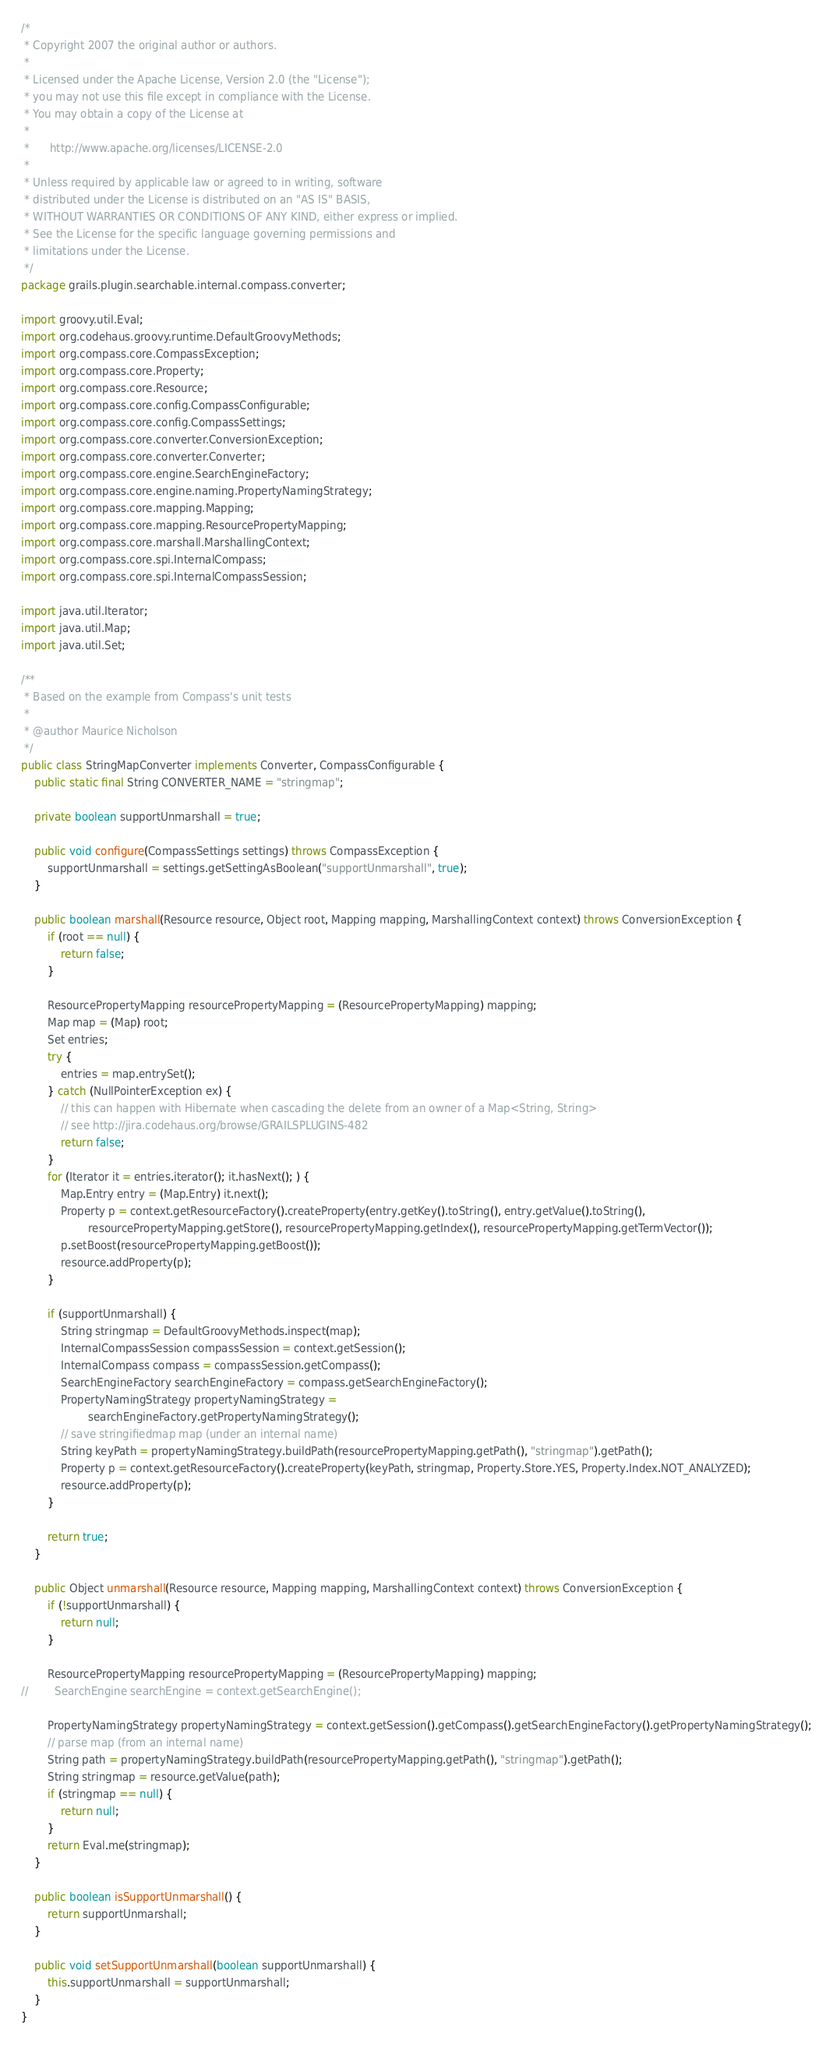<code> <loc_0><loc_0><loc_500><loc_500><_Java_>/*
 * Copyright 2007 the original author or authors.
 *
 * Licensed under the Apache License, Version 2.0 (the "License");
 * you may not use this file except in compliance with the License.
 * You may obtain a copy of the License at
 *
 *      http://www.apache.org/licenses/LICENSE-2.0
 *
 * Unless required by applicable law or agreed to in writing, software
 * distributed under the License is distributed on an "AS IS" BASIS,
 * WITHOUT WARRANTIES OR CONDITIONS OF ANY KIND, either express or implied.
 * See the License for the specific language governing permissions and
 * limitations under the License.
 */
package grails.plugin.searchable.internal.compass.converter;

import groovy.util.Eval;
import org.codehaus.groovy.runtime.DefaultGroovyMethods;
import org.compass.core.CompassException;
import org.compass.core.Property;
import org.compass.core.Resource;
import org.compass.core.config.CompassConfigurable;
import org.compass.core.config.CompassSettings;
import org.compass.core.converter.ConversionException;
import org.compass.core.converter.Converter;
import org.compass.core.engine.SearchEngineFactory;
import org.compass.core.engine.naming.PropertyNamingStrategy;
import org.compass.core.mapping.Mapping;
import org.compass.core.mapping.ResourcePropertyMapping;
import org.compass.core.marshall.MarshallingContext;
import org.compass.core.spi.InternalCompass;
import org.compass.core.spi.InternalCompassSession;

import java.util.Iterator;
import java.util.Map;
import java.util.Set;

/**
 * Based on the example from Compass's unit tests
 *
 * @author Maurice Nicholson
 */
public class StringMapConverter implements Converter, CompassConfigurable {
    public static final String CONVERTER_NAME = "stringmap";

    private boolean supportUnmarshall = true;

    public void configure(CompassSettings settings) throws CompassException {
        supportUnmarshall = settings.getSettingAsBoolean("supportUnmarshall", true);
    }

    public boolean marshall(Resource resource, Object root, Mapping mapping, MarshallingContext context) throws ConversionException {
        if (root == null) {
            return false;
        }

        ResourcePropertyMapping resourcePropertyMapping = (ResourcePropertyMapping) mapping;
        Map map = (Map) root;
        Set entries;
        try {
            entries = map.entrySet();
        } catch (NullPointerException ex) {
            // this can happen with Hibernate when cascading the delete from an owner of a Map<String, String>
            // see http://jira.codehaus.org/browse/GRAILSPLUGINS-482
            return false;
        }
        for (Iterator it = entries.iterator(); it.hasNext(); ) {
            Map.Entry entry = (Map.Entry) it.next();
            Property p = context.getResourceFactory().createProperty(entry.getKey().toString(), entry.getValue().toString(),
                    resourcePropertyMapping.getStore(), resourcePropertyMapping.getIndex(), resourcePropertyMapping.getTermVector());
            p.setBoost(resourcePropertyMapping.getBoost());
            resource.addProperty(p);
        }

        if (supportUnmarshall) {
            String stringmap = DefaultGroovyMethods.inspect(map);
            InternalCompassSession compassSession = context.getSession();
            InternalCompass compass = compassSession.getCompass();
            SearchEngineFactory searchEngineFactory = compass.getSearchEngineFactory();
            PropertyNamingStrategy propertyNamingStrategy =
                    searchEngineFactory.getPropertyNamingStrategy();
            // save stringifiedmap map (under an internal name)
            String keyPath = propertyNamingStrategy.buildPath(resourcePropertyMapping.getPath(), "stringmap").getPath();
            Property p = context.getResourceFactory().createProperty(keyPath, stringmap, Property.Store.YES, Property.Index.NOT_ANALYZED);
            resource.addProperty(p);
        }

        return true;
    }

    public Object unmarshall(Resource resource, Mapping mapping, MarshallingContext context) throws ConversionException {
        if (!supportUnmarshall) {
            return null;
        }

        ResourcePropertyMapping resourcePropertyMapping = (ResourcePropertyMapping) mapping;
//        SearchEngine searchEngine = context.getSearchEngine();

        PropertyNamingStrategy propertyNamingStrategy = context.getSession().getCompass().getSearchEngineFactory().getPropertyNamingStrategy();
        // parse map (from an internal name)
        String path = propertyNamingStrategy.buildPath(resourcePropertyMapping.getPath(), "stringmap").getPath();
        String stringmap = resource.getValue(path);
        if (stringmap == null) {
            return null;
        }
        return Eval.me(stringmap);
    }

    public boolean isSupportUnmarshall() {
        return supportUnmarshall;
    }

    public void setSupportUnmarshall(boolean supportUnmarshall) {
        this.supportUnmarshall = supportUnmarshall;
    }
}
</code> 